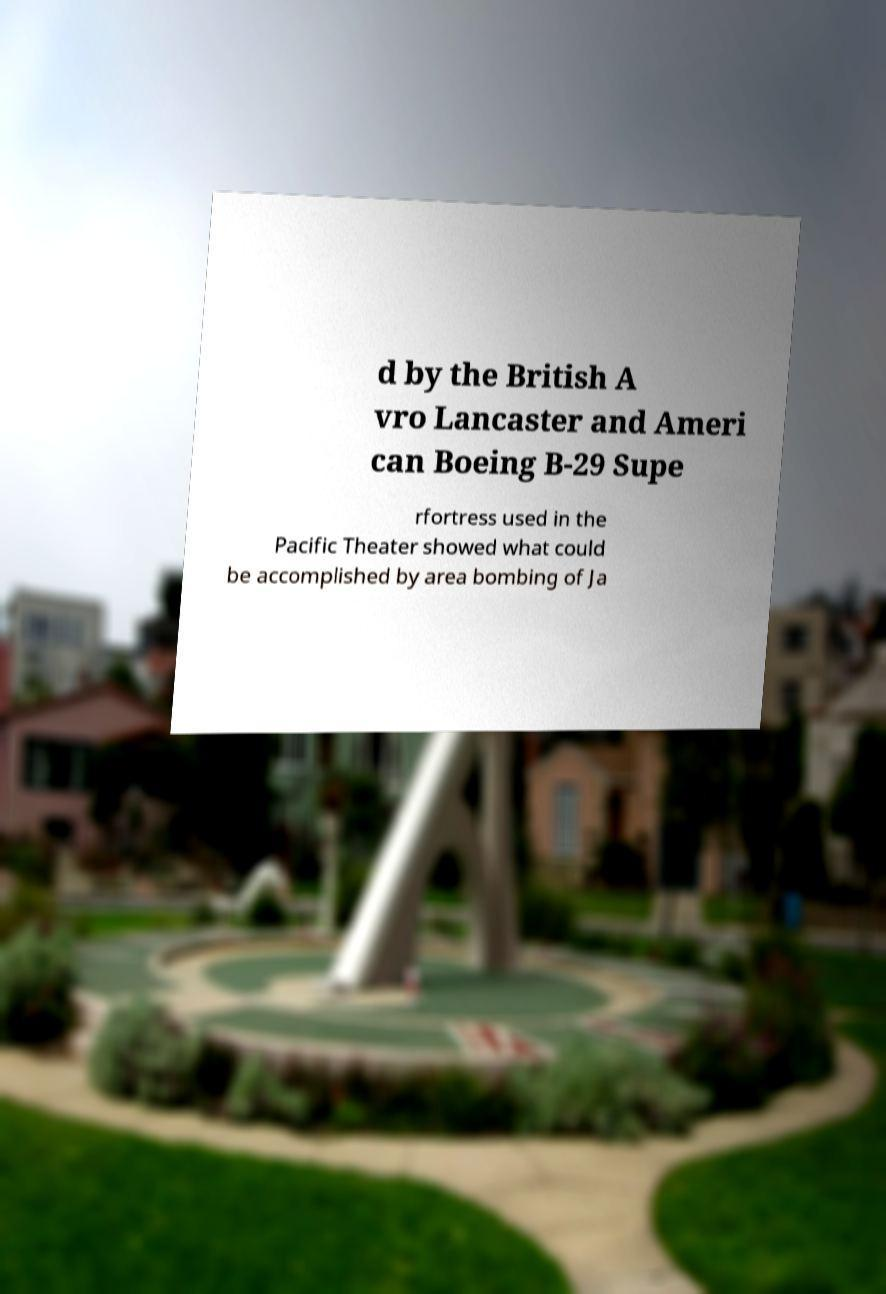I need the written content from this picture converted into text. Can you do that? d by the British A vro Lancaster and Ameri can Boeing B-29 Supe rfortress used in the Pacific Theater showed what could be accomplished by area bombing of Ja 